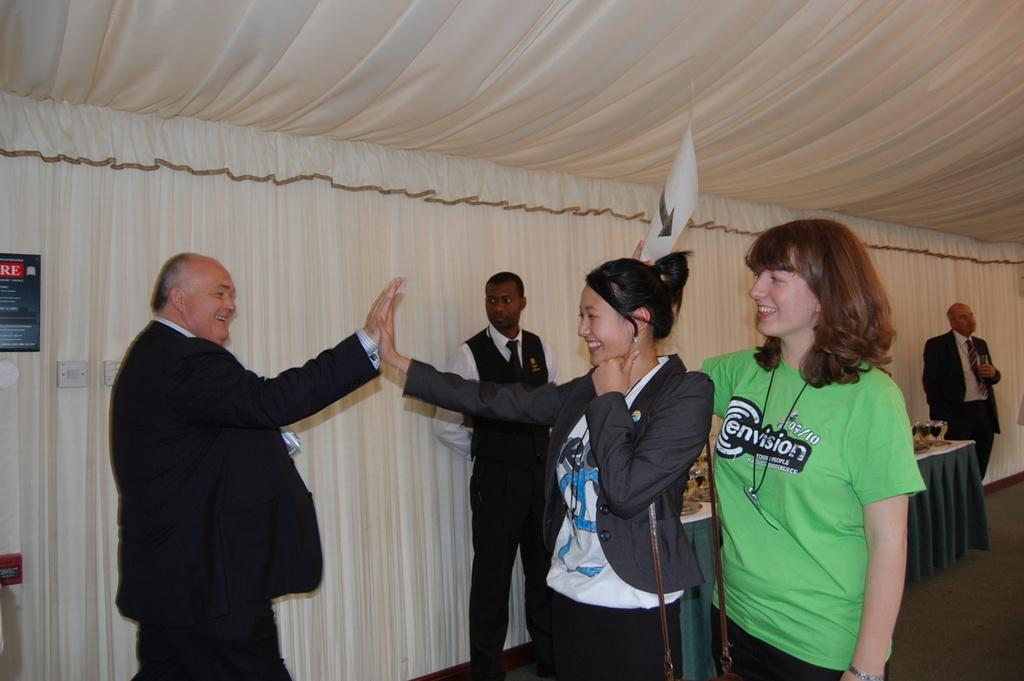How many persons can be seen in the image? There are many persons standing in the center of the image. Where are the persons standing? The persons are standing on the ground. What can be seen in the background of the image? There are curtains, tables, glass tumblers, beverages, and additional persons in the background of the image. What type of tail can be seen on the silver crib in the image? There is no tail or silver crib present in the image. 